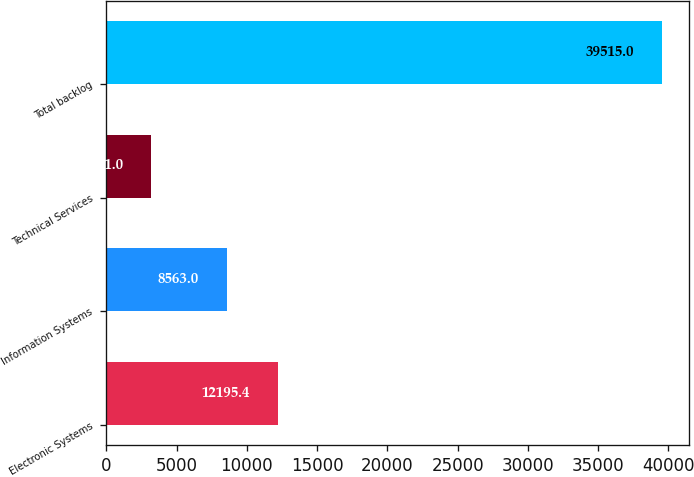Convert chart. <chart><loc_0><loc_0><loc_500><loc_500><bar_chart><fcel>Electronic Systems<fcel>Information Systems<fcel>Technical Services<fcel>Total backlog<nl><fcel>12195.4<fcel>8563<fcel>3191<fcel>39515<nl></chart> 